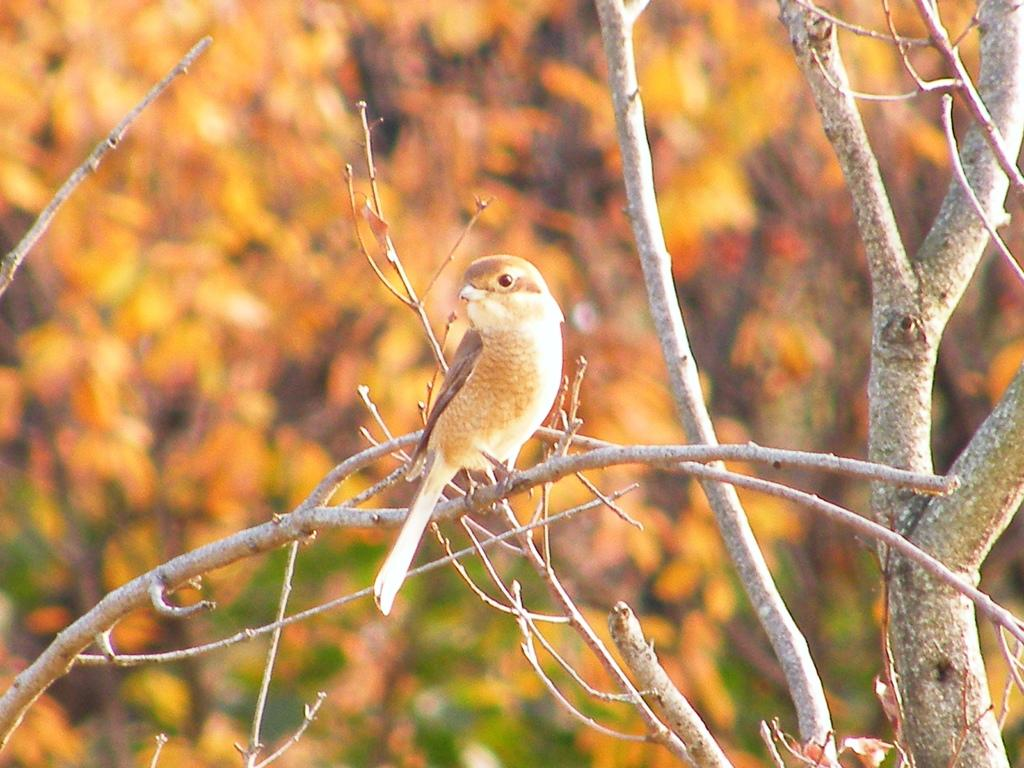What is located in the foreground of the picture? There is a tree in the foreground of the picture. What is on the tree in the image? A bird is sitting on the branches of the tree. How would you describe the background of the image? The background of the image is blurred. Can you see any honey dripping from the branches in the image? There is no honey present in the image; it features a tree with a bird sitting on its branches. 